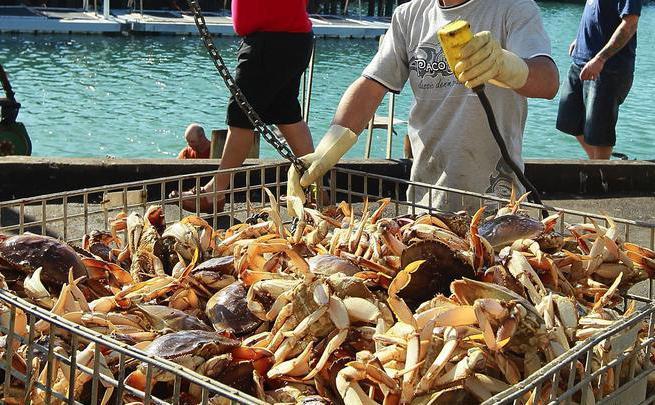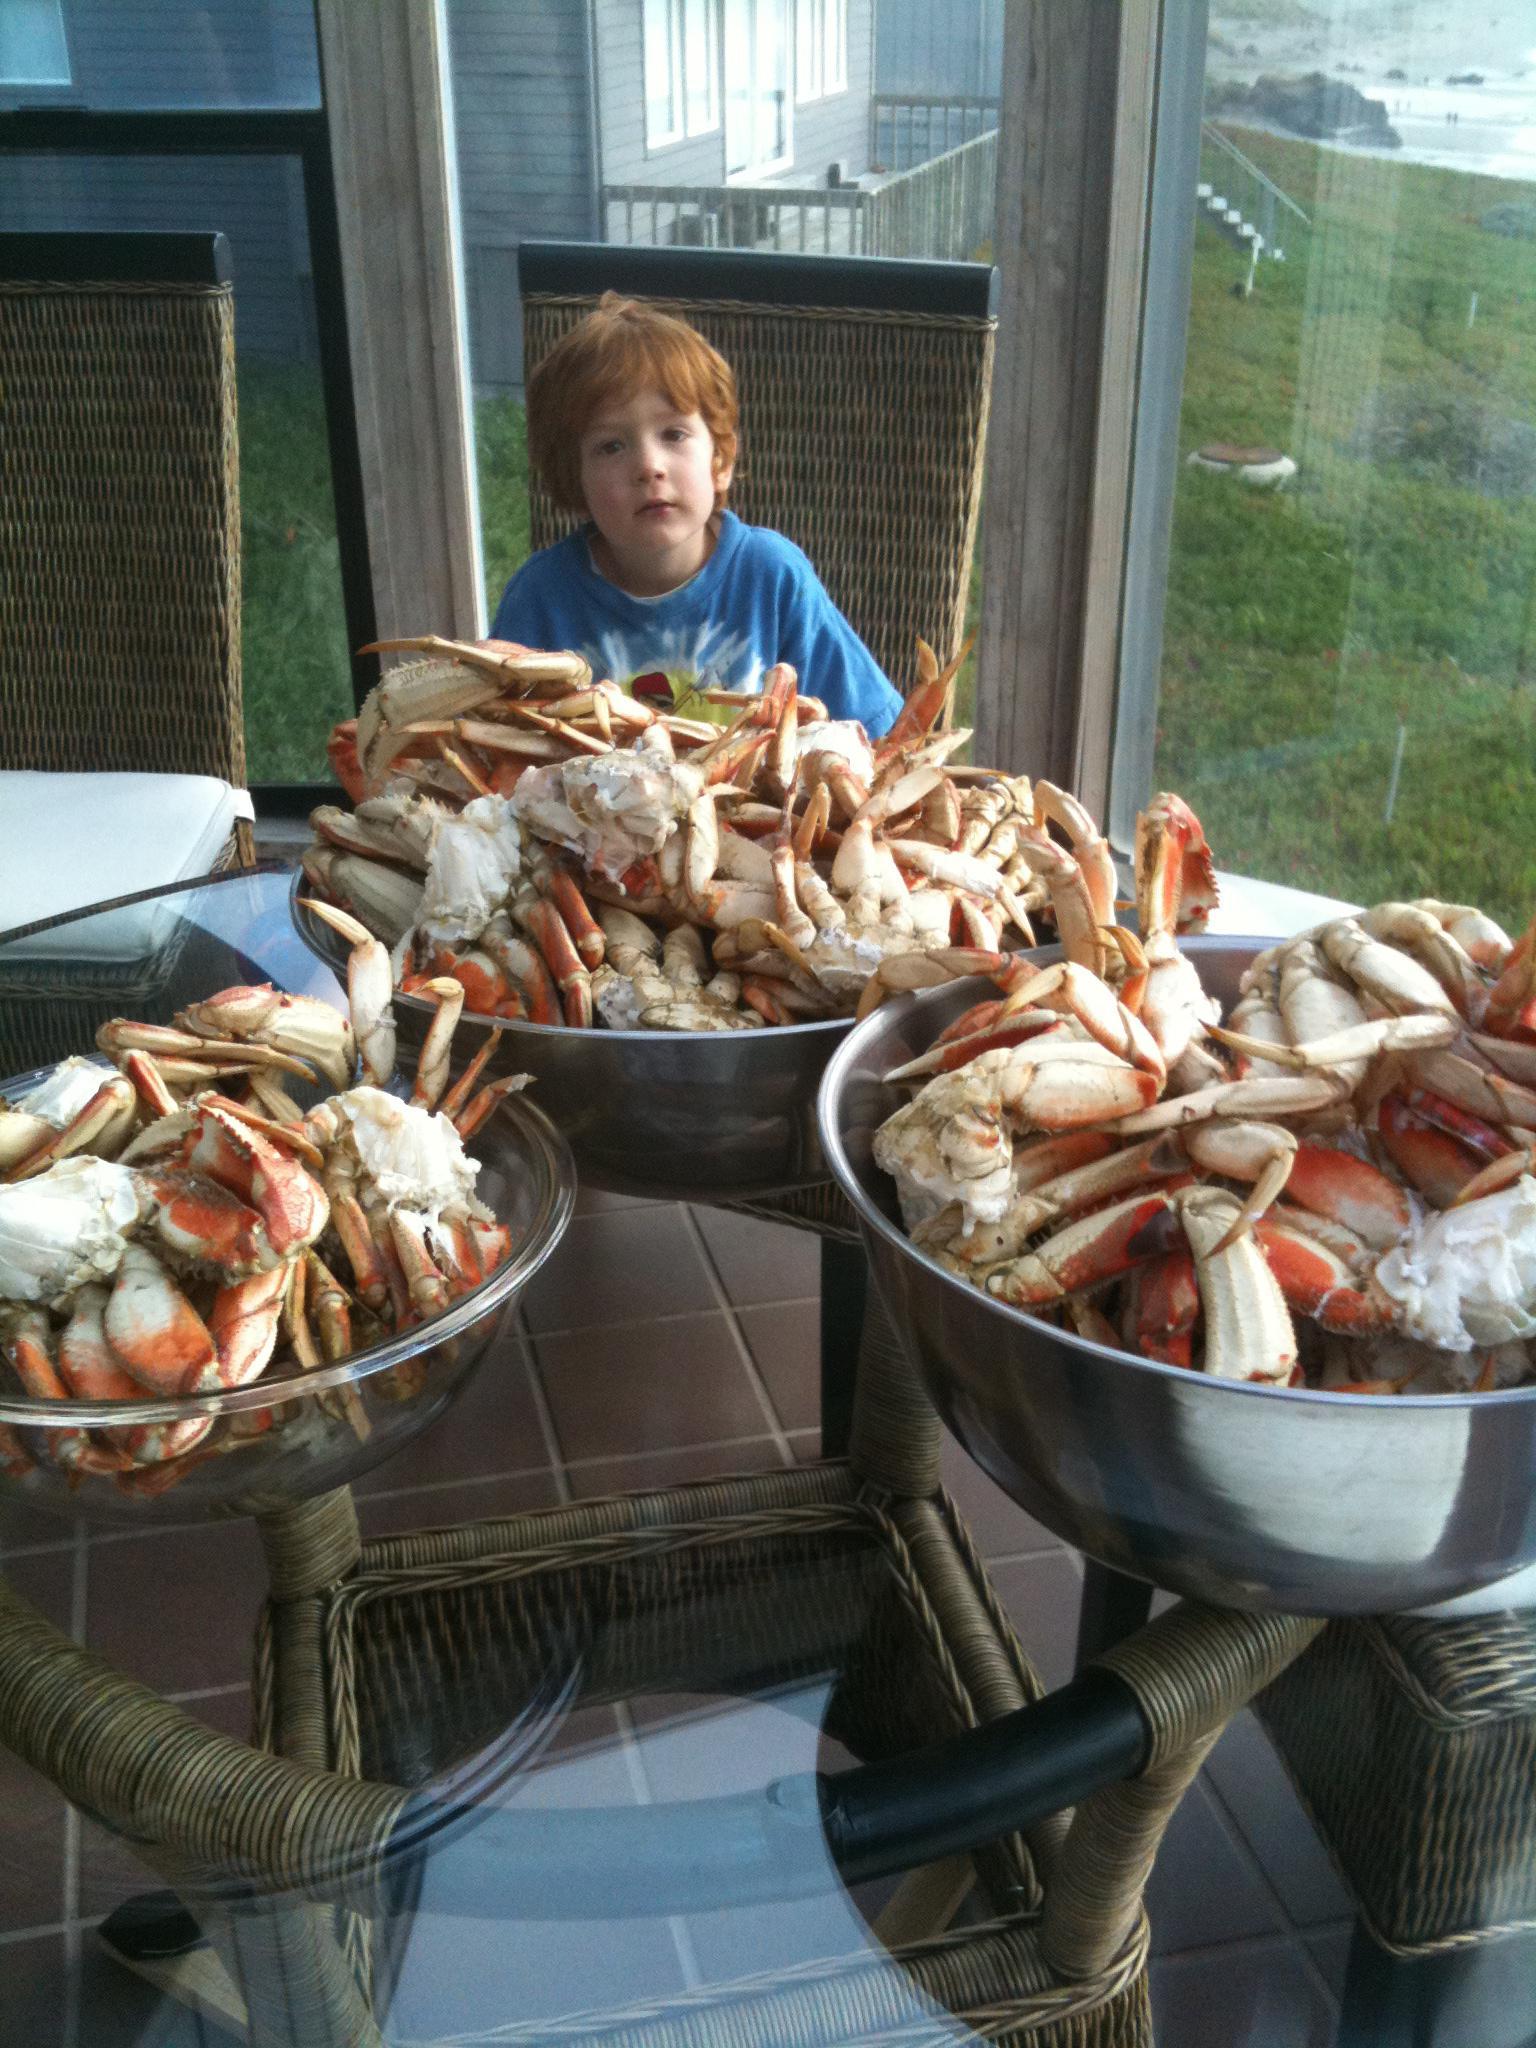The first image is the image on the left, the second image is the image on the right. For the images displayed, is the sentence "In the right image, one woman is sitting at a table behind a round bowl filled with crabs legs, a smaller filled white bowl and other items." factually correct? Answer yes or no. No. The first image is the image on the left, the second image is the image on the right. Given the left and right images, does the statement "A single person who is a woman is sitting behind a platter of seafood in one of the images." hold true? Answer yes or no. No. 